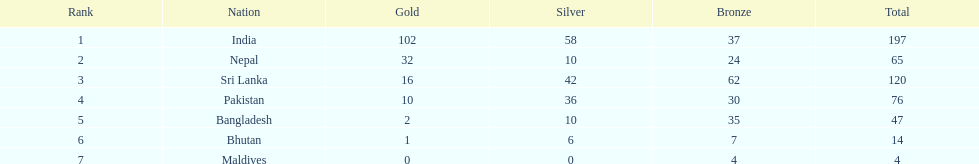In how many countries have the gold medals exceeded 10? 3. 